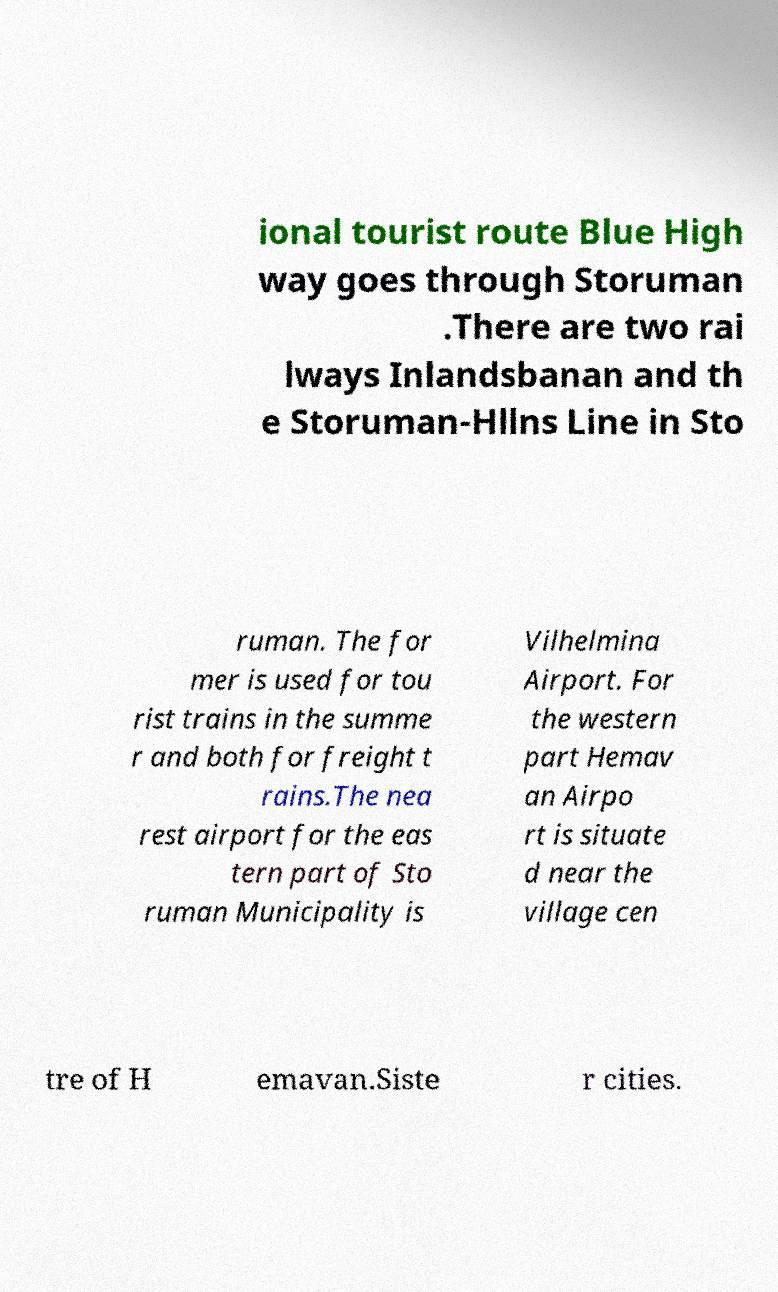Can you accurately transcribe the text from the provided image for me? ional tourist route Blue High way goes through Storuman .There are two rai lways Inlandsbanan and th e Storuman-Hllns Line in Sto ruman. The for mer is used for tou rist trains in the summe r and both for freight t rains.The nea rest airport for the eas tern part of Sto ruman Municipality is Vilhelmina Airport. For the western part Hemav an Airpo rt is situate d near the village cen tre of H emavan.Siste r cities. 